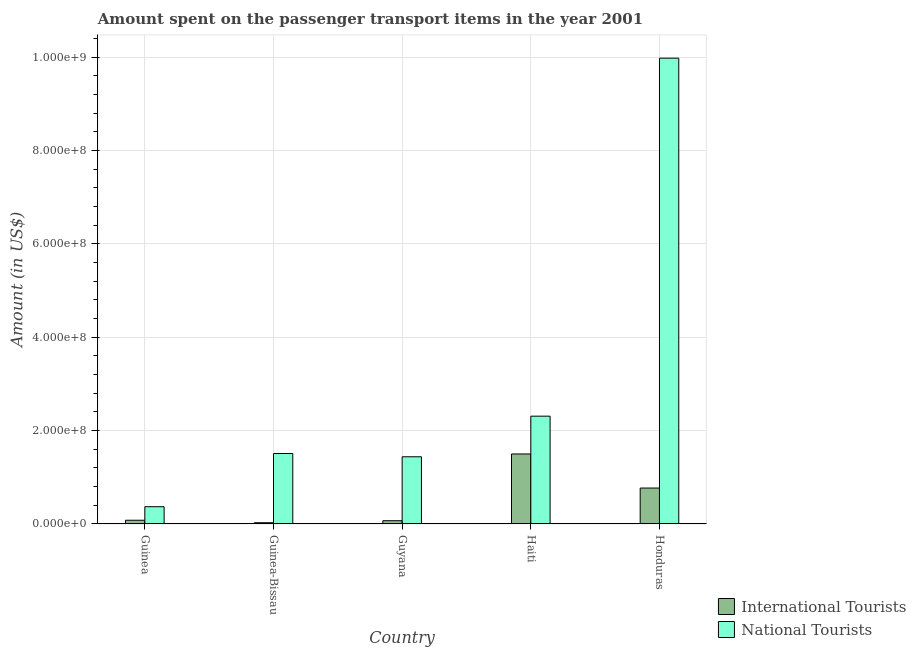How many different coloured bars are there?
Make the answer very short. 2. Are the number of bars on each tick of the X-axis equal?
Your response must be concise. Yes. How many bars are there on the 2nd tick from the left?
Give a very brief answer. 2. What is the label of the 5th group of bars from the left?
Make the answer very short. Honduras. In how many cases, is the number of bars for a given country not equal to the number of legend labels?
Make the answer very short. 0. What is the amount spent on transport items of national tourists in Haiti?
Offer a terse response. 2.31e+08. Across all countries, what is the maximum amount spent on transport items of national tourists?
Provide a succinct answer. 9.98e+08. Across all countries, what is the minimum amount spent on transport items of international tourists?
Offer a terse response. 2.70e+06. In which country was the amount spent on transport items of national tourists maximum?
Ensure brevity in your answer.  Honduras. In which country was the amount spent on transport items of national tourists minimum?
Provide a succinct answer. Guinea. What is the total amount spent on transport items of national tourists in the graph?
Keep it short and to the point. 1.56e+09. What is the difference between the amount spent on transport items of international tourists in Guinea-Bissau and that in Haiti?
Provide a short and direct response. -1.47e+08. What is the difference between the amount spent on transport items of national tourists in Guinea-Bissau and the amount spent on transport items of international tourists in Guinea?
Your answer should be very brief. 1.43e+08. What is the average amount spent on transport items of national tourists per country?
Provide a succinct answer. 3.12e+08. What is the difference between the amount spent on transport items of national tourists and amount spent on transport items of international tourists in Haiti?
Give a very brief answer. 8.10e+07. What is the ratio of the amount spent on transport items of international tourists in Guinea-Bissau to that in Guyana?
Provide a succinct answer. 0.39. Is the difference between the amount spent on transport items of international tourists in Guinea-Bissau and Guyana greater than the difference between the amount spent on transport items of national tourists in Guinea-Bissau and Guyana?
Provide a short and direct response. No. What is the difference between the highest and the second highest amount spent on transport items of international tourists?
Make the answer very short. 7.30e+07. What is the difference between the highest and the lowest amount spent on transport items of national tourists?
Ensure brevity in your answer.  9.61e+08. In how many countries, is the amount spent on transport items of international tourists greater than the average amount spent on transport items of international tourists taken over all countries?
Give a very brief answer. 2. What does the 1st bar from the left in Guinea-Bissau represents?
Your answer should be very brief. International Tourists. What does the 2nd bar from the right in Guyana represents?
Your answer should be compact. International Tourists. How many bars are there?
Provide a short and direct response. 10. Are all the bars in the graph horizontal?
Provide a succinct answer. No. How many countries are there in the graph?
Your response must be concise. 5. Are the values on the major ticks of Y-axis written in scientific E-notation?
Your answer should be compact. Yes. Does the graph contain any zero values?
Make the answer very short. No. Does the graph contain grids?
Give a very brief answer. Yes. Where does the legend appear in the graph?
Your answer should be very brief. Bottom right. How many legend labels are there?
Offer a terse response. 2. How are the legend labels stacked?
Offer a terse response. Vertical. What is the title of the graph?
Give a very brief answer. Amount spent on the passenger transport items in the year 2001. What is the label or title of the X-axis?
Keep it short and to the point. Country. What is the Amount (in US$) in International Tourists in Guinea?
Provide a succinct answer. 8.00e+06. What is the Amount (in US$) of National Tourists in Guinea?
Your answer should be very brief. 3.70e+07. What is the Amount (in US$) in International Tourists in Guinea-Bissau?
Your answer should be very brief. 2.70e+06. What is the Amount (in US$) in National Tourists in Guinea-Bissau?
Your response must be concise. 1.51e+08. What is the Amount (in US$) of International Tourists in Guyana?
Give a very brief answer. 7.00e+06. What is the Amount (in US$) of National Tourists in Guyana?
Provide a short and direct response. 1.44e+08. What is the Amount (in US$) of International Tourists in Haiti?
Make the answer very short. 1.50e+08. What is the Amount (in US$) in National Tourists in Haiti?
Provide a succinct answer. 2.31e+08. What is the Amount (in US$) of International Tourists in Honduras?
Give a very brief answer. 7.70e+07. What is the Amount (in US$) in National Tourists in Honduras?
Give a very brief answer. 9.98e+08. Across all countries, what is the maximum Amount (in US$) of International Tourists?
Your response must be concise. 1.50e+08. Across all countries, what is the maximum Amount (in US$) of National Tourists?
Offer a very short reply. 9.98e+08. Across all countries, what is the minimum Amount (in US$) in International Tourists?
Your response must be concise. 2.70e+06. Across all countries, what is the minimum Amount (in US$) of National Tourists?
Your response must be concise. 3.70e+07. What is the total Amount (in US$) of International Tourists in the graph?
Offer a terse response. 2.45e+08. What is the total Amount (in US$) in National Tourists in the graph?
Provide a short and direct response. 1.56e+09. What is the difference between the Amount (in US$) in International Tourists in Guinea and that in Guinea-Bissau?
Your answer should be compact. 5.30e+06. What is the difference between the Amount (in US$) of National Tourists in Guinea and that in Guinea-Bissau?
Provide a succinct answer. -1.14e+08. What is the difference between the Amount (in US$) in National Tourists in Guinea and that in Guyana?
Offer a very short reply. -1.07e+08. What is the difference between the Amount (in US$) in International Tourists in Guinea and that in Haiti?
Give a very brief answer. -1.42e+08. What is the difference between the Amount (in US$) of National Tourists in Guinea and that in Haiti?
Provide a short and direct response. -1.94e+08. What is the difference between the Amount (in US$) in International Tourists in Guinea and that in Honduras?
Give a very brief answer. -6.90e+07. What is the difference between the Amount (in US$) of National Tourists in Guinea and that in Honduras?
Your answer should be very brief. -9.61e+08. What is the difference between the Amount (in US$) of International Tourists in Guinea-Bissau and that in Guyana?
Offer a terse response. -4.30e+06. What is the difference between the Amount (in US$) in International Tourists in Guinea-Bissau and that in Haiti?
Your response must be concise. -1.47e+08. What is the difference between the Amount (in US$) in National Tourists in Guinea-Bissau and that in Haiti?
Make the answer very short. -8.00e+07. What is the difference between the Amount (in US$) of International Tourists in Guinea-Bissau and that in Honduras?
Your response must be concise. -7.43e+07. What is the difference between the Amount (in US$) of National Tourists in Guinea-Bissau and that in Honduras?
Your answer should be compact. -8.47e+08. What is the difference between the Amount (in US$) of International Tourists in Guyana and that in Haiti?
Your response must be concise. -1.43e+08. What is the difference between the Amount (in US$) of National Tourists in Guyana and that in Haiti?
Give a very brief answer. -8.70e+07. What is the difference between the Amount (in US$) in International Tourists in Guyana and that in Honduras?
Provide a short and direct response. -7.00e+07. What is the difference between the Amount (in US$) in National Tourists in Guyana and that in Honduras?
Keep it short and to the point. -8.54e+08. What is the difference between the Amount (in US$) in International Tourists in Haiti and that in Honduras?
Make the answer very short. 7.30e+07. What is the difference between the Amount (in US$) of National Tourists in Haiti and that in Honduras?
Offer a terse response. -7.67e+08. What is the difference between the Amount (in US$) in International Tourists in Guinea and the Amount (in US$) in National Tourists in Guinea-Bissau?
Your response must be concise. -1.43e+08. What is the difference between the Amount (in US$) in International Tourists in Guinea and the Amount (in US$) in National Tourists in Guyana?
Keep it short and to the point. -1.36e+08. What is the difference between the Amount (in US$) of International Tourists in Guinea and the Amount (in US$) of National Tourists in Haiti?
Your answer should be very brief. -2.23e+08. What is the difference between the Amount (in US$) of International Tourists in Guinea and the Amount (in US$) of National Tourists in Honduras?
Your answer should be compact. -9.90e+08. What is the difference between the Amount (in US$) of International Tourists in Guinea-Bissau and the Amount (in US$) of National Tourists in Guyana?
Your answer should be compact. -1.41e+08. What is the difference between the Amount (in US$) in International Tourists in Guinea-Bissau and the Amount (in US$) in National Tourists in Haiti?
Provide a succinct answer. -2.28e+08. What is the difference between the Amount (in US$) in International Tourists in Guinea-Bissau and the Amount (in US$) in National Tourists in Honduras?
Keep it short and to the point. -9.95e+08. What is the difference between the Amount (in US$) of International Tourists in Guyana and the Amount (in US$) of National Tourists in Haiti?
Make the answer very short. -2.24e+08. What is the difference between the Amount (in US$) of International Tourists in Guyana and the Amount (in US$) of National Tourists in Honduras?
Provide a short and direct response. -9.91e+08. What is the difference between the Amount (in US$) of International Tourists in Haiti and the Amount (in US$) of National Tourists in Honduras?
Your response must be concise. -8.48e+08. What is the average Amount (in US$) of International Tourists per country?
Provide a short and direct response. 4.89e+07. What is the average Amount (in US$) of National Tourists per country?
Make the answer very short. 3.12e+08. What is the difference between the Amount (in US$) of International Tourists and Amount (in US$) of National Tourists in Guinea?
Give a very brief answer. -2.90e+07. What is the difference between the Amount (in US$) of International Tourists and Amount (in US$) of National Tourists in Guinea-Bissau?
Offer a terse response. -1.48e+08. What is the difference between the Amount (in US$) in International Tourists and Amount (in US$) in National Tourists in Guyana?
Keep it short and to the point. -1.37e+08. What is the difference between the Amount (in US$) of International Tourists and Amount (in US$) of National Tourists in Haiti?
Offer a very short reply. -8.10e+07. What is the difference between the Amount (in US$) of International Tourists and Amount (in US$) of National Tourists in Honduras?
Keep it short and to the point. -9.21e+08. What is the ratio of the Amount (in US$) of International Tourists in Guinea to that in Guinea-Bissau?
Ensure brevity in your answer.  2.96. What is the ratio of the Amount (in US$) of National Tourists in Guinea to that in Guinea-Bissau?
Offer a very short reply. 0.24. What is the ratio of the Amount (in US$) of International Tourists in Guinea to that in Guyana?
Your answer should be compact. 1.14. What is the ratio of the Amount (in US$) of National Tourists in Guinea to that in Guyana?
Offer a terse response. 0.26. What is the ratio of the Amount (in US$) of International Tourists in Guinea to that in Haiti?
Keep it short and to the point. 0.05. What is the ratio of the Amount (in US$) in National Tourists in Guinea to that in Haiti?
Provide a succinct answer. 0.16. What is the ratio of the Amount (in US$) of International Tourists in Guinea to that in Honduras?
Provide a short and direct response. 0.1. What is the ratio of the Amount (in US$) in National Tourists in Guinea to that in Honduras?
Offer a very short reply. 0.04. What is the ratio of the Amount (in US$) in International Tourists in Guinea-Bissau to that in Guyana?
Keep it short and to the point. 0.39. What is the ratio of the Amount (in US$) of National Tourists in Guinea-Bissau to that in Guyana?
Provide a short and direct response. 1.05. What is the ratio of the Amount (in US$) in International Tourists in Guinea-Bissau to that in Haiti?
Provide a short and direct response. 0.02. What is the ratio of the Amount (in US$) of National Tourists in Guinea-Bissau to that in Haiti?
Provide a short and direct response. 0.65. What is the ratio of the Amount (in US$) in International Tourists in Guinea-Bissau to that in Honduras?
Provide a succinct answer. 0.04. What is the ratio of the Amount (in US$) of National Tourists in Guinea-Bissau to that in Honduras?
Ensure brevity in your answer.  0.15. What is the ratio of the Amount (in US$) in International Tourists in Guyana to that in Haiti?
Offer a very short reply. 0.05. What is the ratio of the Amount (in US$) in National Tourists in Guyana to that in Haiti?
Keep it short and to the point. 0.62. What is the ratio of the Amount (in US$) in International Tourists in Guyana to that in Honduras?
Give a very brief answer. 0.09. What is the ratio of the Amount (in US$) of National Tourists in Guyana to that in Honduras?
Offer a very short reply. 0.14. What is the ratio of the Amount (in US$) of International Tourists in Haiti to that in Honduras?
Your answer should be compact. 1.95. What is the ratio of the Amount (in US$) of National Tourists in Haiti to that in Honduras?
Your response must be concise. 0.23. What is the difference between the highest and the second highest Amount (in US$) of International Tourists?
Keep it short and to the point. 7.30e+07. What is the difference between the highest and the second highest Amount (in US$) in National Tourists?
Your answer should be compact. 7.67e+08. What is the difference between the highest and the lowest Amount (in US$) in International Tourists?
Ensure brevity in your answer.  1.47e+08. What is the difference between the highest and the lowest Amount (in US$) of National Tourists?
Ensure brevity in your answer.  9.61e+08. 